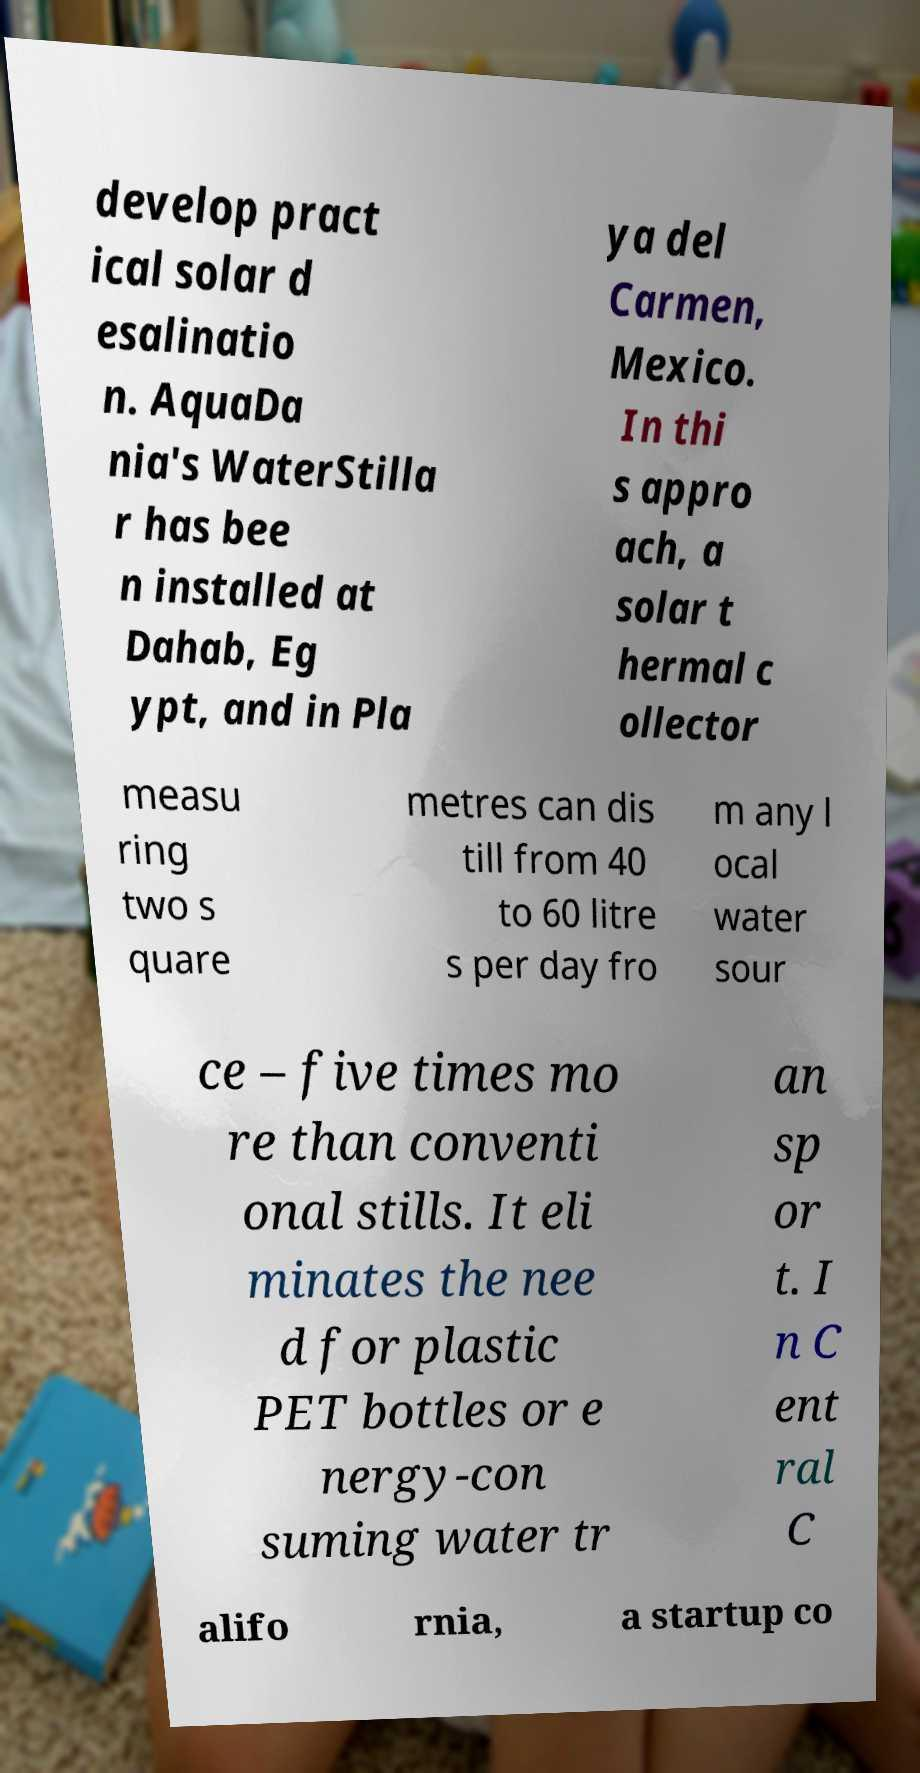Can you accurately transcribe the text from the provided image for me? develop pract ical solar d esalinatio n. AquaDa nia's WaterStilla r has bee n installed at Dahab, Eg ypt, and in Pla ya del Carmen, Mexico. In thi s appro ach, a solar t hermal c ollector measu ring two s quare metres can dis till from 40 to 60 litre s per day fro m any l ocal water sour ce – five times mo re than conventi onal stills. It eli minates the nee d for plastic PET bottles or e nergy-con suming water tr an sp or t. I n C ent ral C alifo rnia, a startup co 